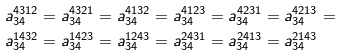Convert formula to latex. <formula><loc_0><loc_0><loc_500><loc_500>a _ { 3 4 } ^ { 4 3 1 2 } & = a _ { 3 4 } ^ { 4 3 2 1 } = a _ { 3 4 } ^ { 4 1 3 2 } = a _ { 3 4 } ^ { 4 1 2 3 } = a _ { 3 4 } ^ { 4 2 3 1 } = a _ { 3 4 } ^ { 4 2 1 3 } = \\ a _ { 3 4 } ^ { 1 4 3 2 } & = a _ { 3 4 } ^ { 1 4 2 3 } = a _ { 3 4 } ^ { 1 2 4 3 } = a _ { 3 4 } ^ { 2 4 3 1 } = a _ { 3 4 } ^ { 2 4 1 3 } = a _ { 3 4 } ^ { 2 1 4 3 }</formula> 